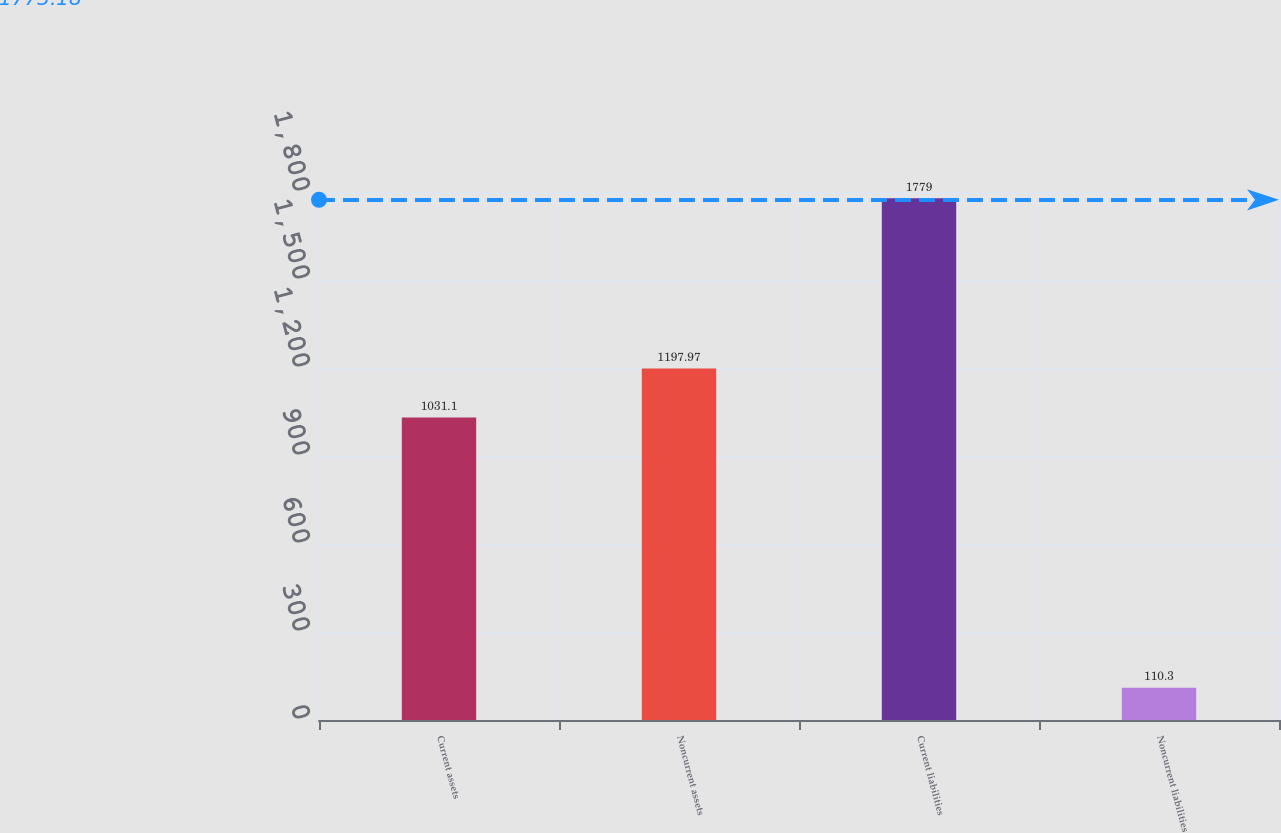Convert chart. <chart><loc_0><loc_0><loc_500><loc_500><bar_chart><fcel>Current assets<fcel>Noncurrent assets<fcel>Current liabilities<fcel>Noncurrent liabilities<nl><fcel>1031.1<fcel>1197.97<fcel>1779<fcel>110.3<nl></chart> 